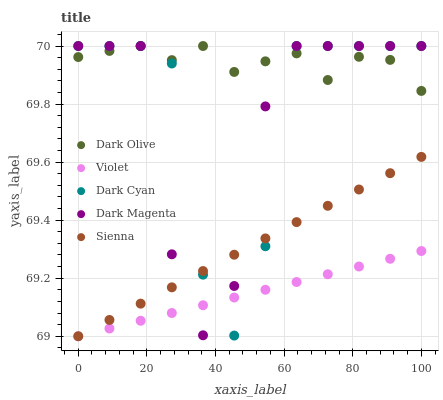Does Violet have the minimum area under the curve?
Answer yes or no. Yes. Does Dark Olive have the maximum area under the curve?
Answer yes or no. Yes. Does Sienna have the minimum area under the curve?
Answer yes or no. No. Does Sienna have the maximum area under the curve?
Answer yes or no. No. Is Violet the smoothest?
Answer yes or no. Yes. Is Dark Cyan the roughest?
Answer yes or no. Yes. Is Sienna the smoothest?
Answer yes or no. No. Is Sienna the roughest?
Answer yes or no. No. Does Sienna have the lowest value?
Answer yes or no. Yes. Does Dark Olive have the lowest value?
Answer yes or no. No. Does Dark Magenta have the highest value?
Answer yes or no. Yes. Does Sienna have the highest value?
Answer yes or no. No. Is Sienna less than Dark Olive?
Answer yes or no. Yes. Is Dark Olive greater than Violet?
Answer yes or no. Yes. Does Dark Magenta intersect Violet?
Answer yes or no. Yes. Is Dark Magenta less than Violet?
Answer yes or no. No. Is Dark Magenta greater than Violet?
Answer yes or no. No. Does Sienna intersect Dark Olive?
Answer yes or no. No. 